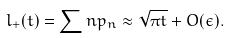<formula> <loc_0><loc_0><loc_500><loc_500>l _ { + } ( t ) = \sum n p _ { n } \approx \sqrt { \pi t } + O ( \epsilon ) .</formula> 